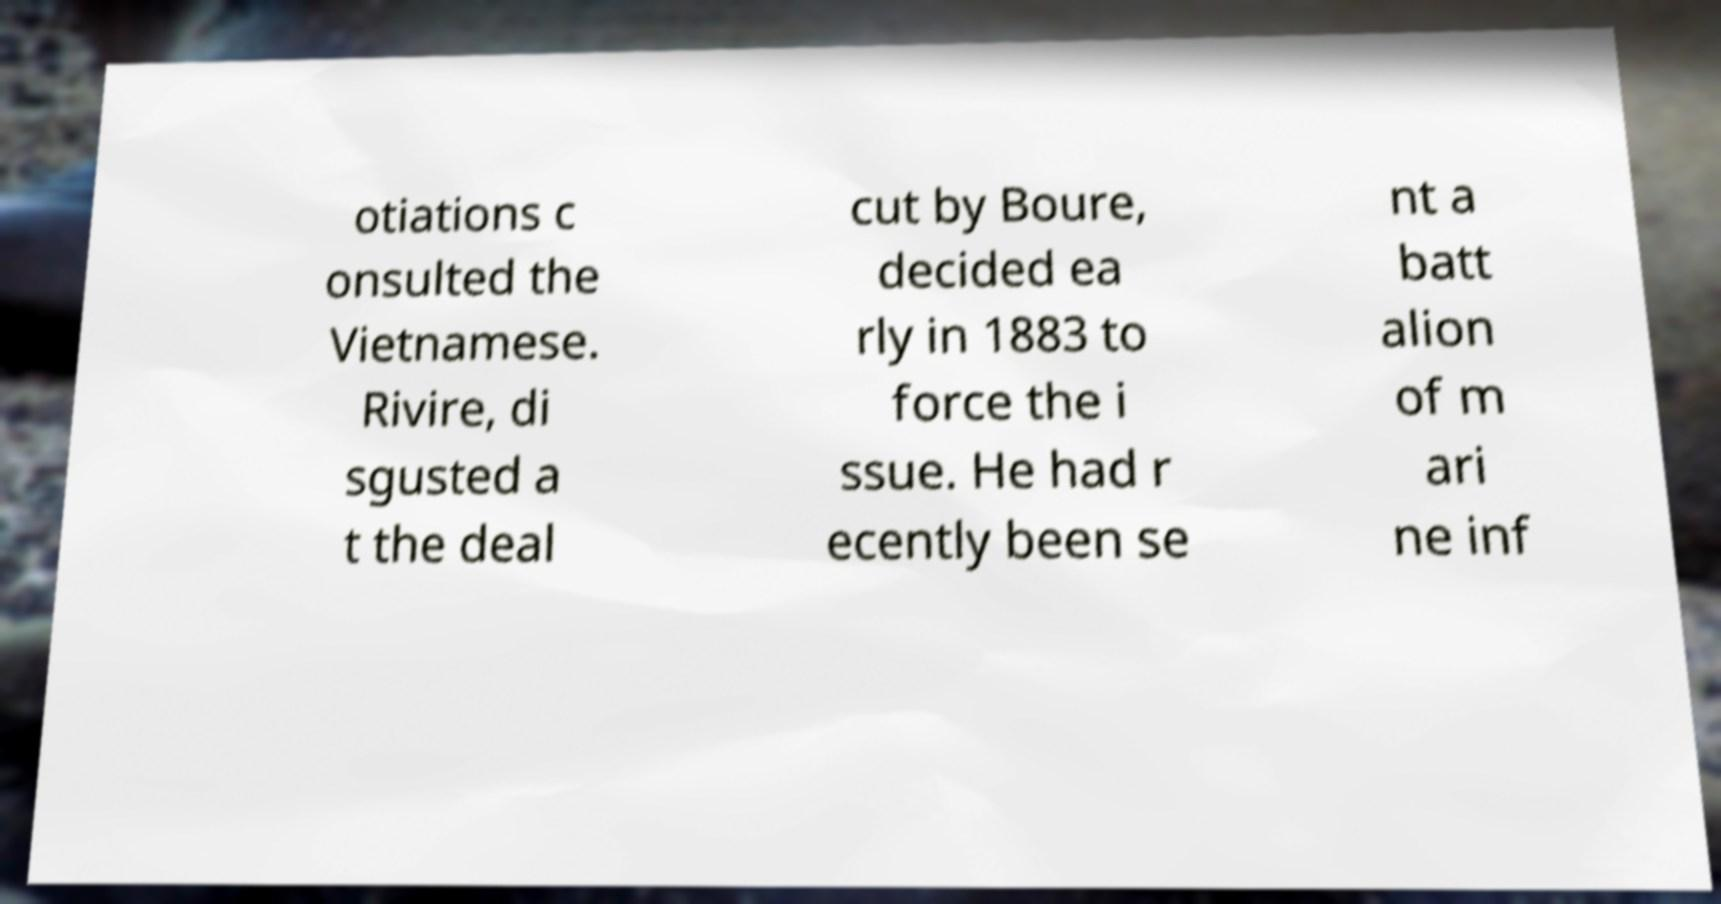Could you extract and type out the text from this image? otiations c onsulted the Vietnamese. Rivire, di sgusted a t the deal cut by Boure, decided ea rly in 1883 to force the i ssue. He had r ecently been se nt a batt alion of m ari ne inf 